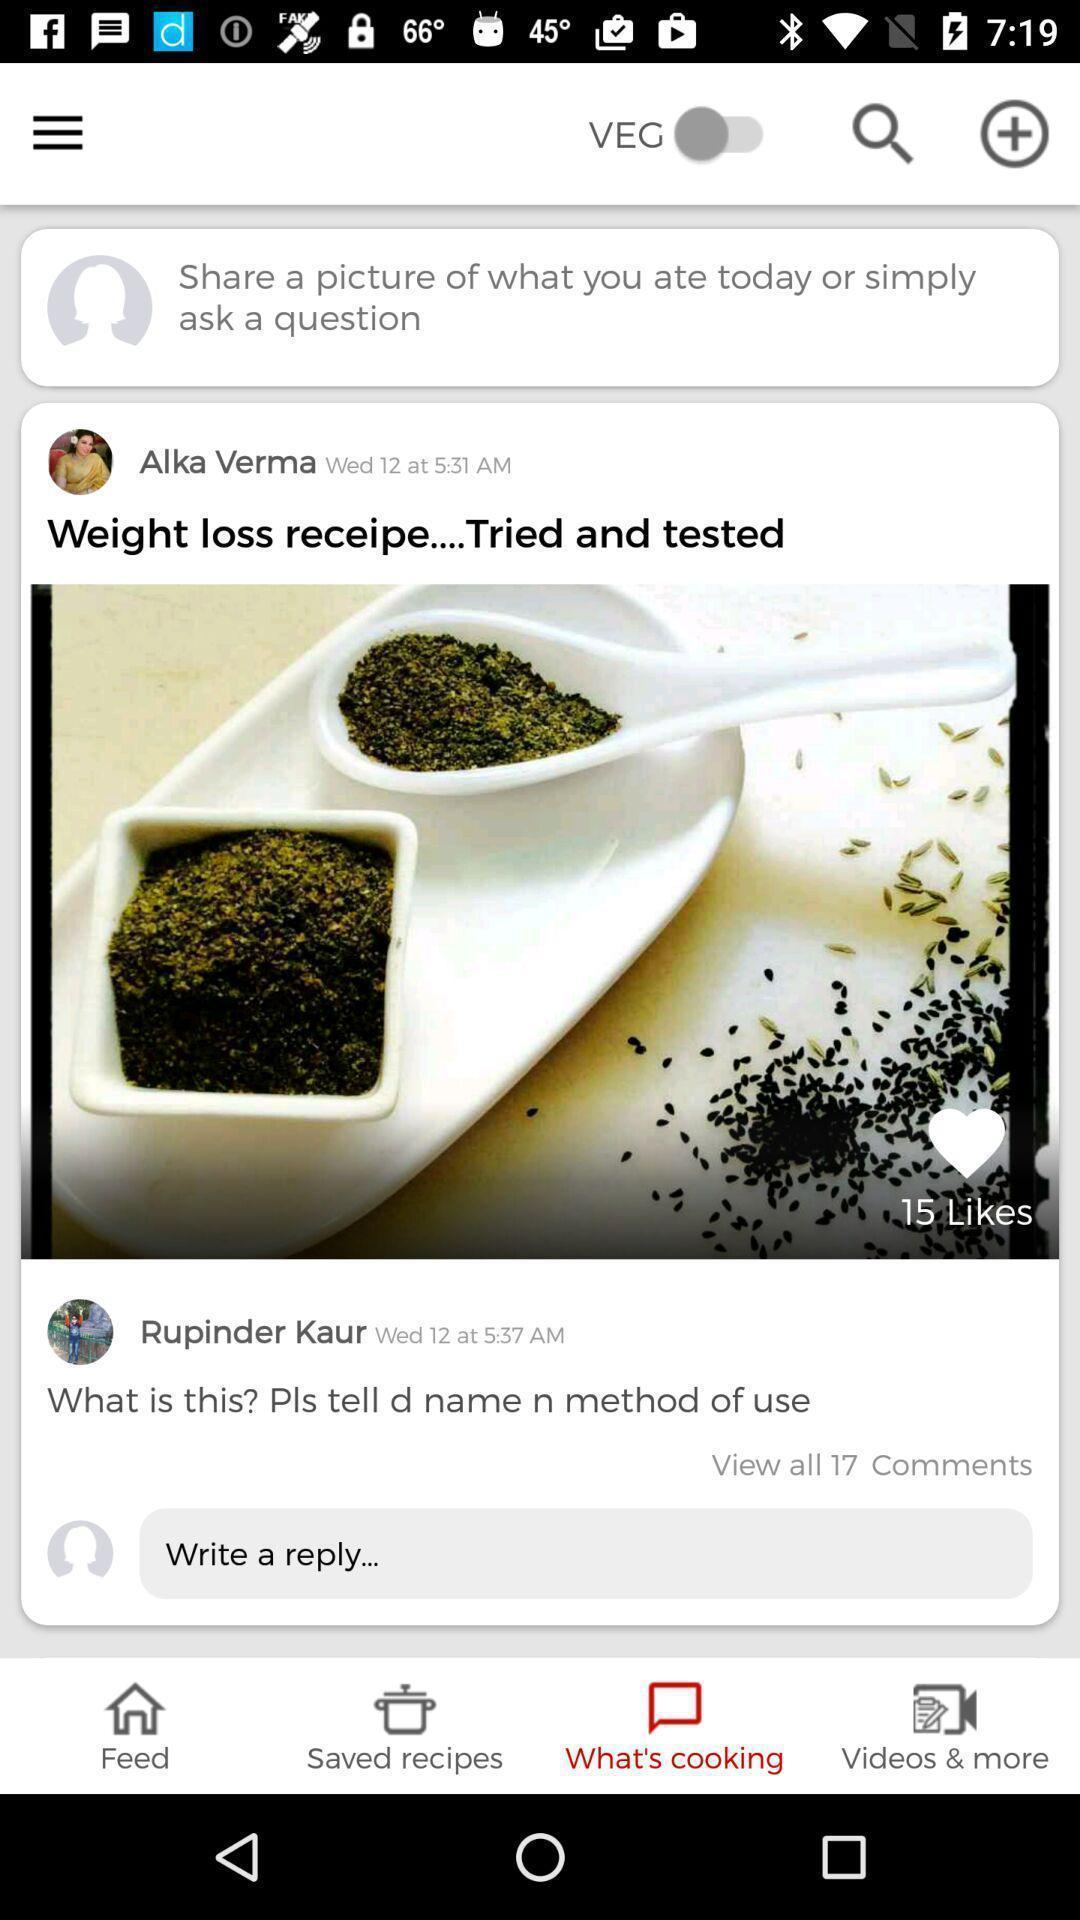Describe the content in this image. Weight loss receipe showing in application. 